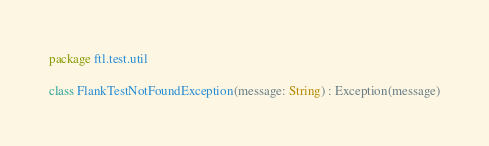<code> <loc_0><loc_0><loc_500><loc_500><_Kotlin_>package ftl.test.util

class FlankTestNotFoundException(message: String) : Exception(message)
</code> 